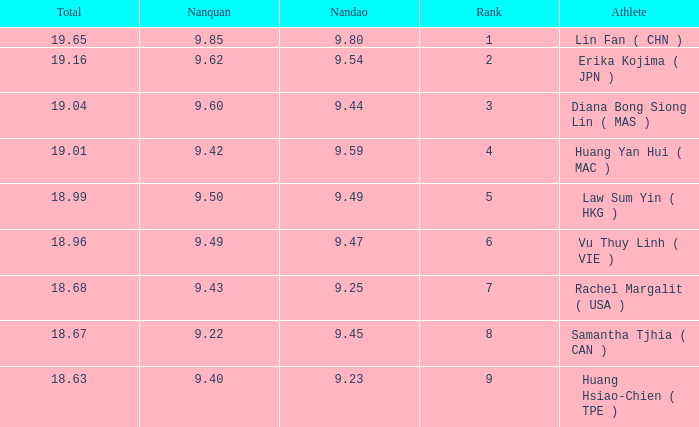Which Nanquan has a Nandao larger than 9.49, and a Rank of 4? 9.42. 